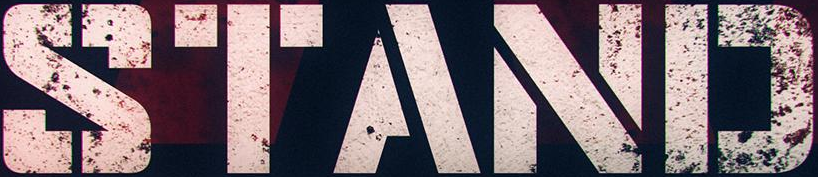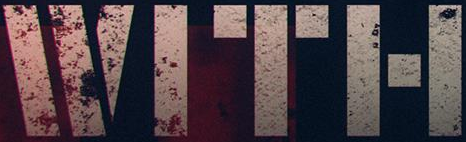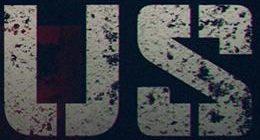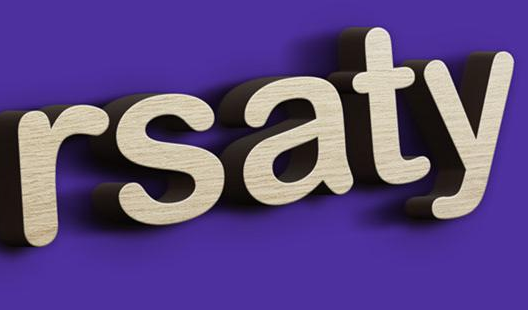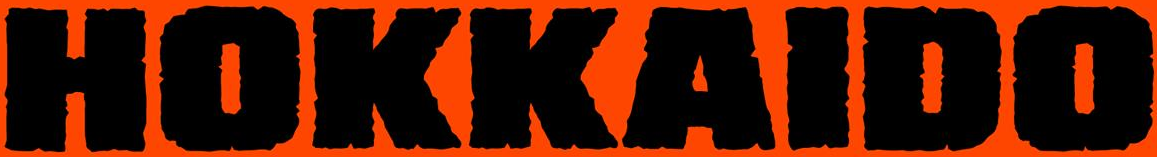What words are shown in these images in order, separated by a semicolon? STAND; WITH; US; rsaty; HOKKAIDO 